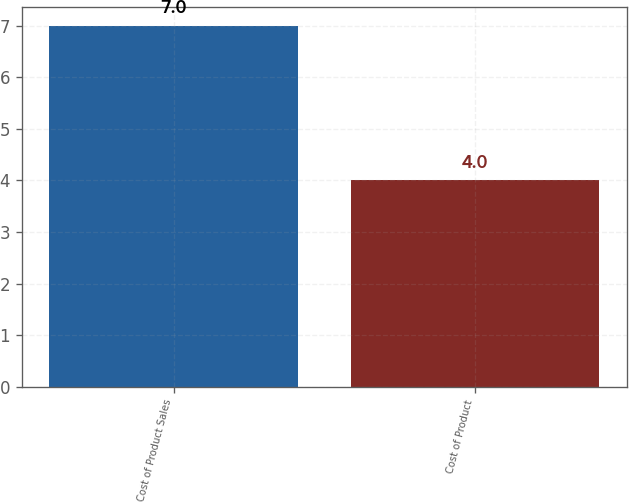Convert chart. <chart><loc_0><loc_0><loc_500><loc_500><bar_chart><fcel>Cost of Product Sales<fcel>Cost of Product<nl><fcel>7<fcel>4<nl></chart> 